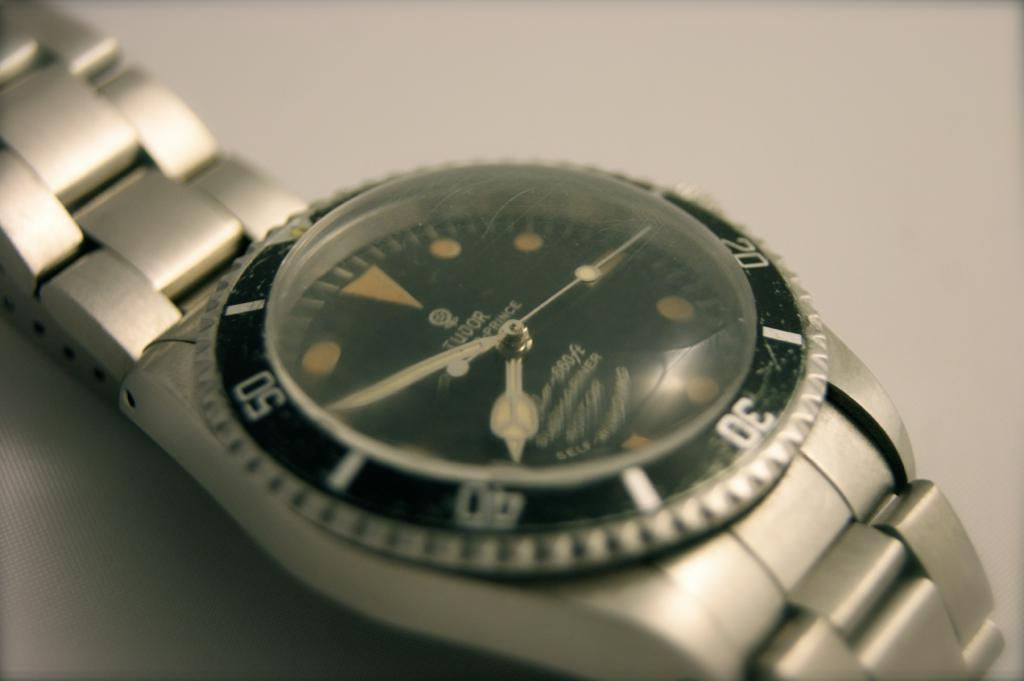<image>
Describe the image concisely. A Tudor brand silver wrist watch is self winding 